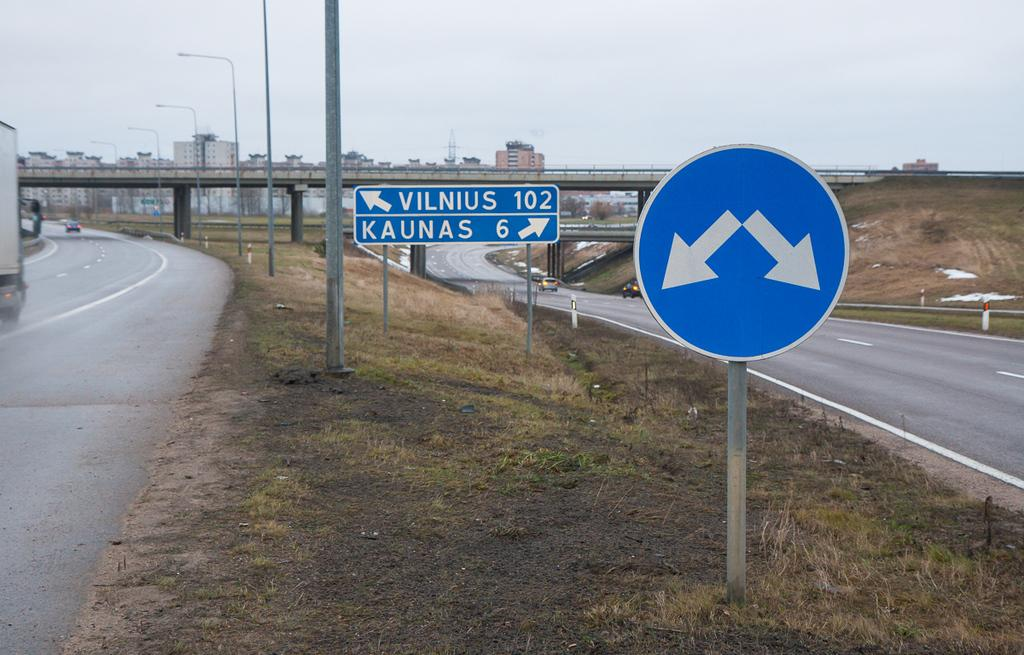What can be seen at the front of the image? There are signboards, poles, roads, and vehicles at the front of the image. Can you describe the background of the image? In the background, there is a bridge, light poles, pillars, buildings, and the sky. What type of infrastructure is present in the image? The image features roads, a bridge, and buildings. Are there any man-made structures visible in the image? Yes, there are signboards, poles, a bridge, light poles, pillars, and buildings visible in the image. Are there any slaves depicted in the image? There is no mention or depiction of slaves in the image. What type of shop can be seen in the background of the image? There is no shop visible in the image. Can you see any cords hanging from the light poles in the background? There is no mention of cords hanging from the light poles in the image. 